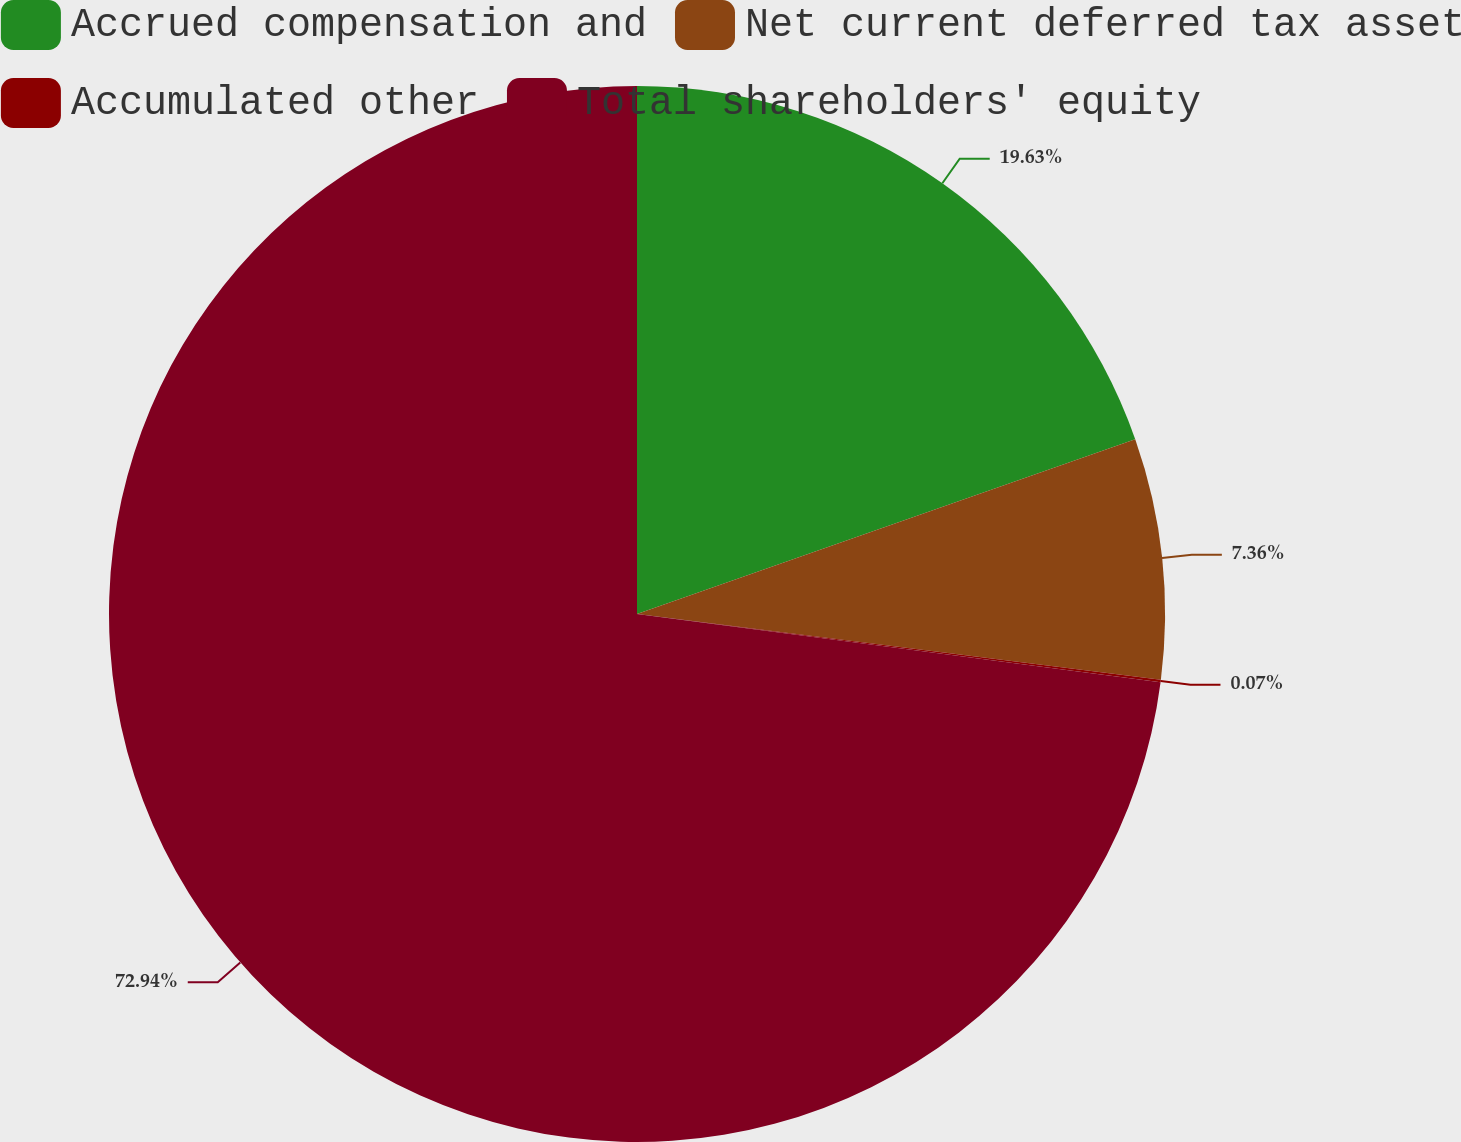Convert chart. <chart><loc_0><loc_0><loc_500><loc_500><pie_chart><fcel>Accrued compensation and<fcel>Net current deferred tax asset<fcel>Accumulated other<fcel>Total shareholders' equity<nl><fcel>19.63%<fcel>7.36%<fcel>0.07%<fcel>72.94%<nl></chart> 